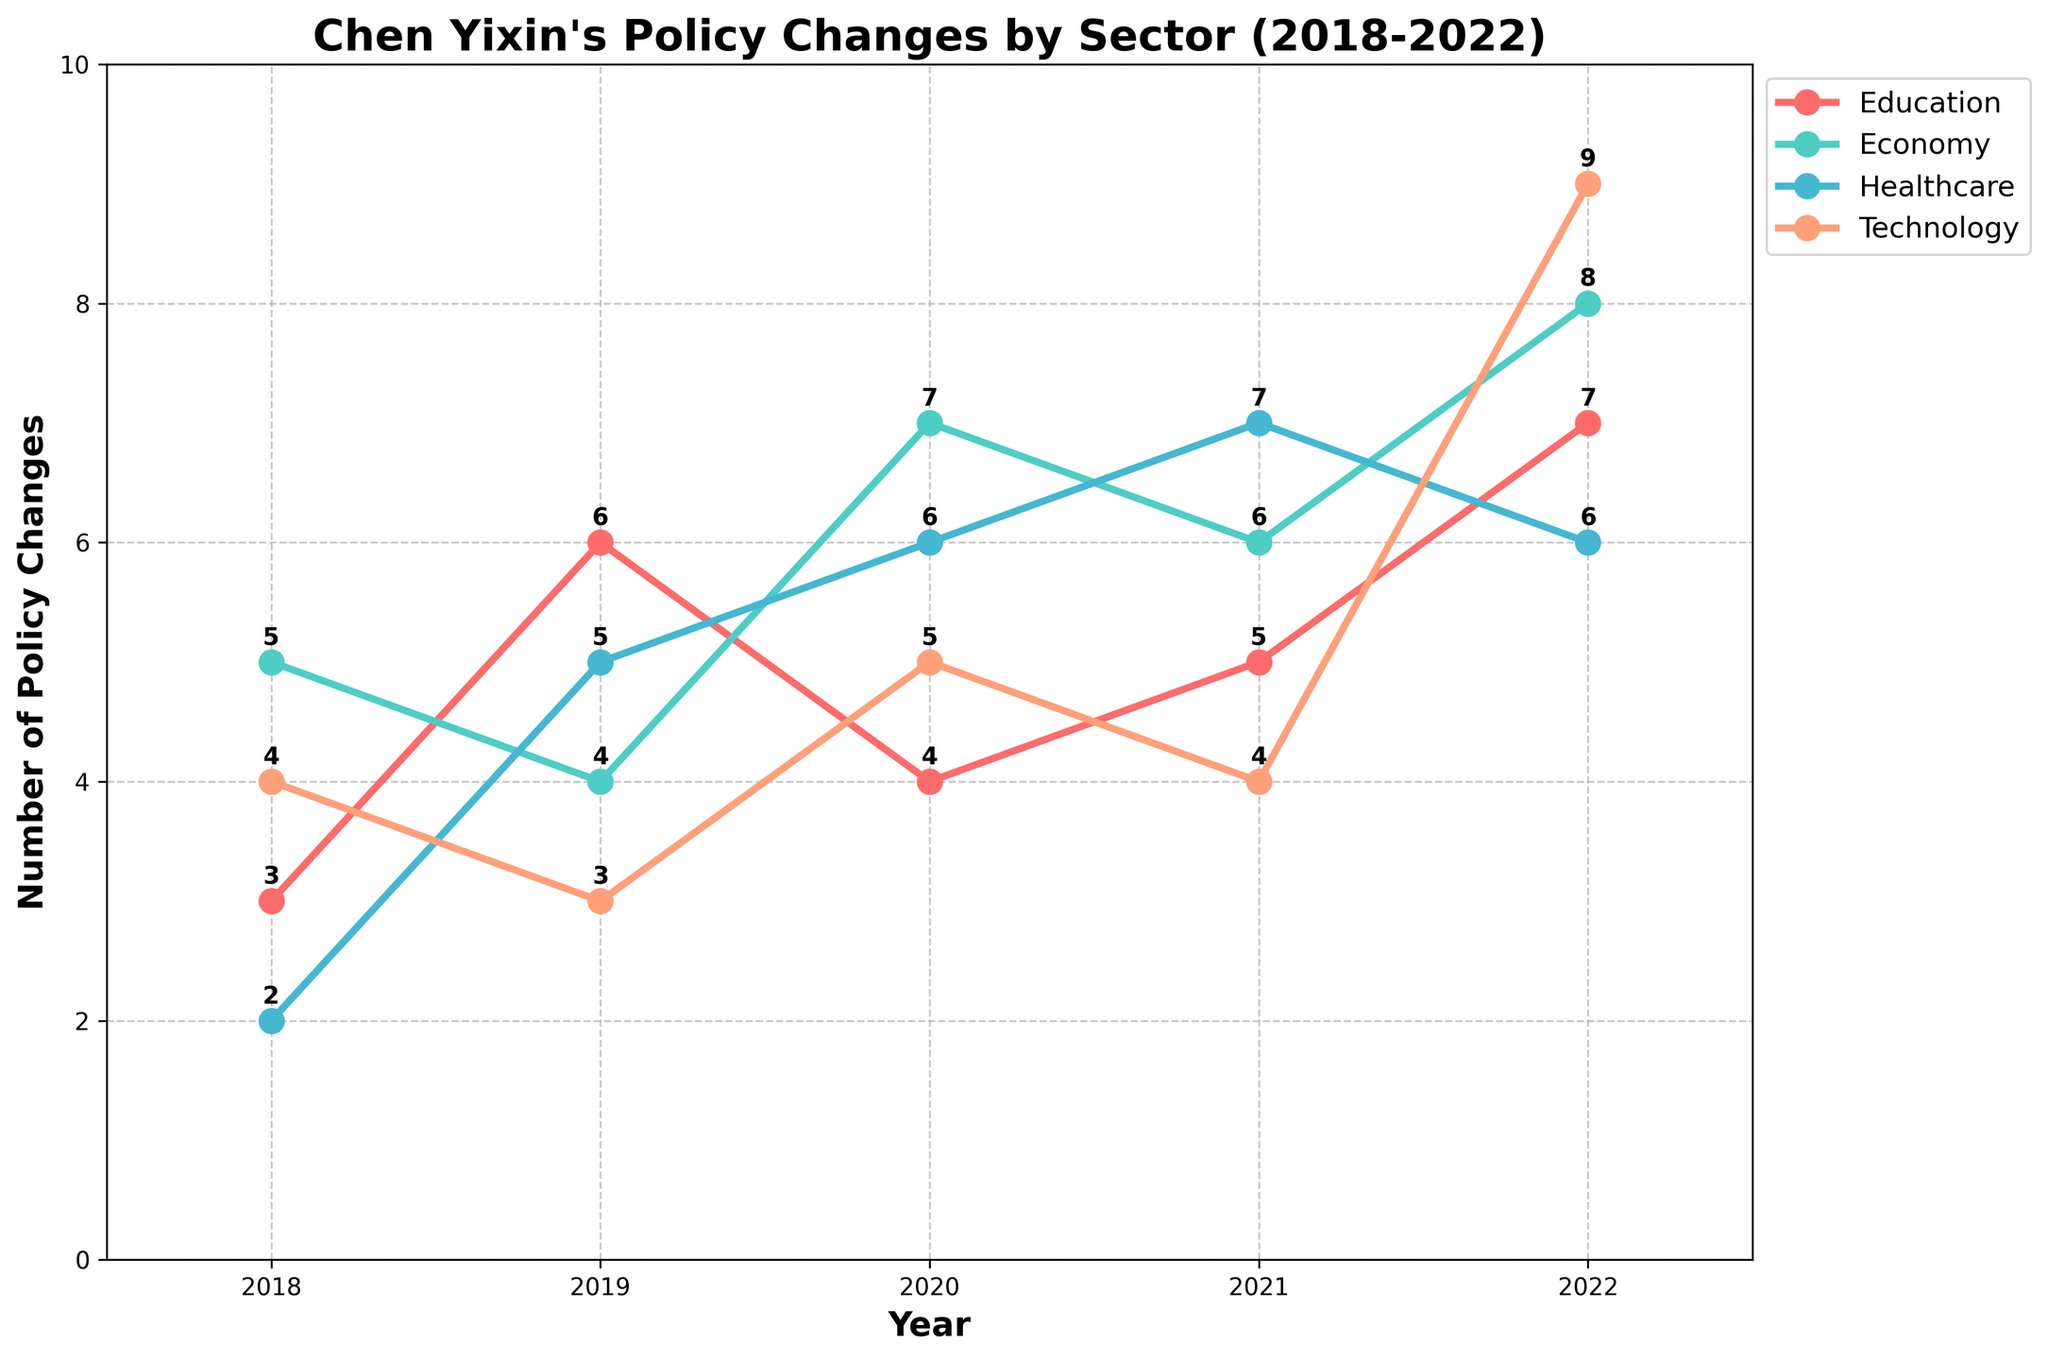Which sector had the highest number of policy changes in 2022? To answer this, look at the data points for each sector in the year 2022. The highest value is 9, which belongs to the Technology sector.
Answer: Technology How many policy changes were made in the Healthcare sector in 2019? Look at the point corresponding to 2019 in the Healthcare sector line. The number of policy changes is 5.
Answer: 5 Which year saw the highest number of policy changes in the Economy sector? Examine the line representing the Economy sector. The highest point is in the year 2022, with 8 policy changes.
Answer: 2022 What is the trend in the number of policy changes in the Education sector from 2018 to 2022? Observe the Education sector line from 2018 to 2022. It starts at 3 in 2018, rises to 6 in 2019, decreases to 4 in 2020, increases to 5 in 2021, and reaches 7 in 2022. Overall, the trend is upward.
Answer: Upward Which sector had the least number of policy changes overall from 2018 to 2022? Compare the points for all sectors across all years. The Healthcare sector has the lowest cumulative values over the years with 2, 5, 6, 7, 6 totaling 26.
Answer: Healthcare Between 2020 and 2021, which sector saw an increase in policy changes? Look at the lines from 2020 to 2021. The sectors with increases are Education (from 4 to 5), Healthcare (from 6 to 7), Economy (remains constant but not an increase), and Technology (from 5 to 4 which is a decrease so not applicable).
Answer: Education and Healthcare What is the total number of policy changes in the Technology sector over the 5 years? Add the values of the Technology sector from 2018 to 2022: 4 + 3 + 5 + 4 + 9 = 25.
Answer: 25 Which sector had the highest average number of policy changes per year? Calculate average for each sector: 
Education: (3+6+4+5+7)/5 = 5 
Economy: (5+4+7+6+8)/5 = 6 
Healthcare: (2+5+6+7+6)/5 = 5.2 
Technology: (4+3+5+4+9)/5 = 5 
The highest average is 6 for the Economy sector.
Answer: Economy How many policy changes were introduced across all sectors in 2020? Sum all the policy changes in 2020: 4 (Education) + 7 (Economy) + 6 (Healthcare) + 5 (Technology) = 22.
Answer: 22 